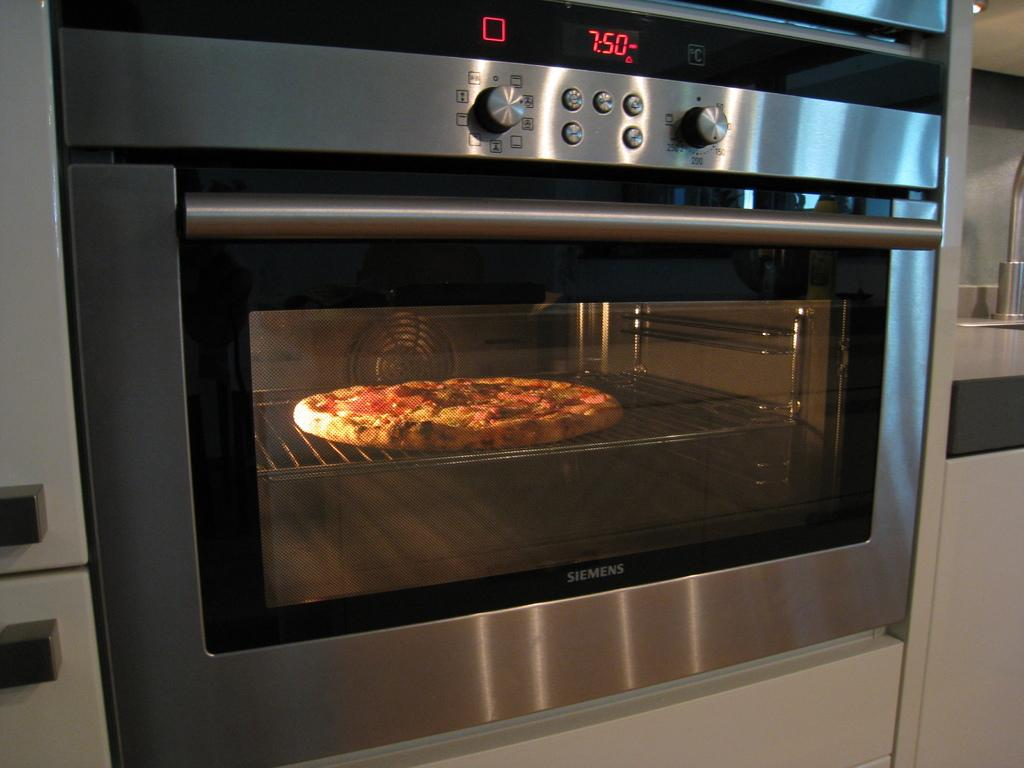Provide a one-sentence caption for the provided image. a pizza baking in the oven with digital numbers 750 in red on it. 